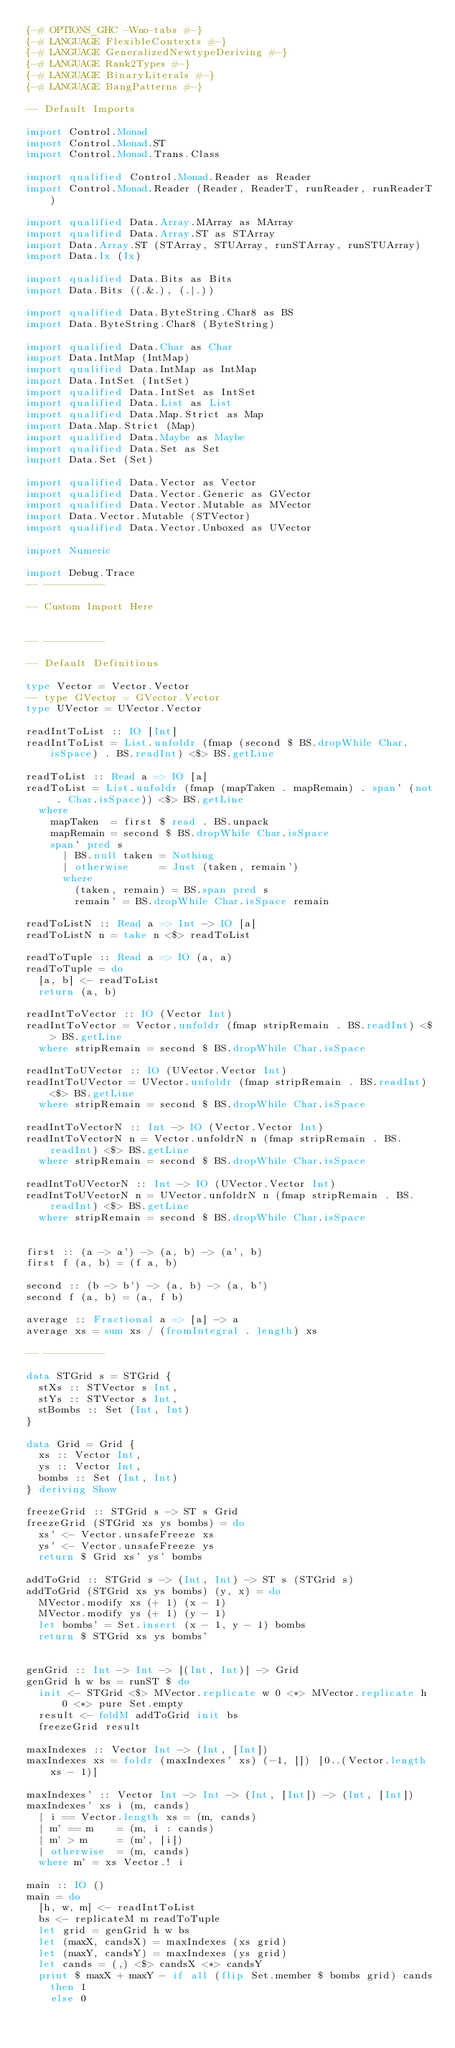Convert code to text. <code><loc_0><loc_0><loc_500><loc_500><_Haskell_>{-# OPTIONS_GHC -Wno-tabs #-}
{-# LANGUAGE FlexibleContexts #-}
{-# LANGUAGE GeneralizedNewtypeDeriving #-}
{-# LANGUAGE Rank2Types #-}
{-# LANGUAGE BinaryLiterals #-}
{-# LANGUAGE BangPatterns #-}

-- Default Imports

import Control.Monad
import Control.Monad.ST
import Control.Monad.Trans.Class

import qualified Control.Monad.Reader as Reader
import Control.Monad.Reader (Reader, ReaderT, runReader, runReaderT)

import qualified Data.Array.MArray as MArray
import qualified Data.Array.ST as STArray
import Data.Array.ST (STArray, STUArray, runSTArray, runSTUArray)
import Data.Ix (Ix)

import qualified Data.Bits as Bits
import Data.Bits ((.&.), (.|.))

import qualified Data.ByteString.Char8 as BS
import Data.ByteString.Char8 (ByteString)

import qualified Data.Char as Char
import Data.IntMap (IntMap)
import qualified Data.IntMap as IntMap
import Data.IntSet (IntSet)
import qualified Data.IntSet as IntSet
import qualified Data.List as List
import qualified Data.Map.Strict as Map
import Data.Map.Strict (Map)
import qualified Data.Maybe as Maybe
import qualified Data.Set as Set
import Data.Set (Set)

import qualified Data.Vector as Vector
import qualified Data.Vector.Generic as GVector
import qualified Data.Vector.Mutable as MVector
import Data.Vector.Mutable (STVector)
import qualified Data.Vector.Unboxed as UVector

import Numeric

import Debug.Trace
-- ----------

-- Custom Import Here


-- ----------

-- Default Definitions

type Vector = Vector.Vector
-- type GVector = GVector.Vector
type UVector = UVector.Vector

readIntToList :: IO [Int]
readIntToList = List.unfoldr (fmap (second $ BS.dropWhile Char.isSpace) . BS.readInt) <$> BS.getLine

readToList :: Read a => IO [a]
readToList = List.unfoldr (fmap (mapTaken . mapRemain) . span' (not . Char.isSpace)) <$> BS.getLine
	where
		mapTaken  = first $ read . BS.unpack
		mapRemain = second $ BS.dropWhile Char.isSpace
		span' pred s
			| BS.null taken = Nothing
			| otherwise     = Just (taken, remain')
			where
				(taken, remain) = BS.span pred s
				remain' = BS.dropWhile Char.isSpace remain

readToListN :: Read a => Int -> IO [a]
readToListN n = take n <$> readToList

readToTuple :: Read a => IO (a, a)
readToTuple = do
	[a, b] <- readToList
	return (a, b)

readIntToVector :: IO (Vector Int)
readIntToVector = Vector.unfoldr (fmap stripRemain . BS.readInt) <$> BS.getLine
	where stripRemain = second $ BS.dropWhile Char.isSpace

readIntToUVector :: IO (UVector.Vector Int)
readIntToUVector = UVector.unfoldr (fmap stripRemain . BS.readInt) <$> BS.getLine
	where stripRemain = second $ BS.dropWhile Char.isSpace

readIntToVectorN :: Int -> IO (Vector.Vector Int)
readIntToVectorN n = Vector.unfoldrN n (fmap stripRemain . BS.readInt) <$> BS.getLine
	where stripRemain = second $ BS.dropWhile Char.isSpace

readIntToUVectorN :: Int -> IO (UVector.Vector Int)
readIntToUVectorN n = UVector.unfoldrN n (fmap stripRemain . BS.readInt) <$> BS.getLine
	where stripRemain = second $ BS.dropWhile Char.isSpace


first :: (a -> a') -> (a, b) -> (a', b)
first f (a, b) = (f a, b)

second :: (b -> b') -> (a, b) -> (a, b')
second f (a, b) = (a, f b)

average :: Fractional a => [a] -> a
average xs = sum xs / (fromIntegral . length) xs

-- ----------

data STGrid s = STGrid {
	stXs :: STVector s Int,
	stYs :: STVector s Int,
	stBombs :: Set (Int, Int)
}

data Grid = Grid {
	xs :: Vector Int,
	ys :: Vector Int,
	bombs :: Set (Int, Int)
} deriving Show

freezeGrid :: STGrid s -> ST s Grid
freezeGrid (STGrid xs ys bombs) = do
	xs' <- Vector.unsafeFreeze xs
	ys' <- Vector.unsafeFreeze ys
	return $ Grid xs' ys' bombs

addToGrid :: STGrid s -> (Int, Int) -> ST s (STGrid s)
addToGrid (STGrid xs ys bombs) (y, x) = do
	MVector.modify xs (+ 1) (x - 1)
	MVector.modify ys (+ 1) (y - 1)
	let bombs' = Set.insert (x - 1, y - 1) bombs
	return $ STGrid xs ys bombs'


genGrid :: Int -> Int -> [(Int, Int)] -> Grid
genGrid h w bs = runST $ do
	init <- STGrid <$> MVector.replicate w 0 <*> MVector.replicate h 0 <*> pure Set.empty
	result <- foldM addToGrid init bs
	freezeGrid result

maxIndexes :: Vector Int -> (Int, [Int])
maxIndexes xs = foldr (maxIndexes' xs) (-1, []) [0..(Vector.length xs - 1)]

maxIndexes' :: Vector Int -> Int -> (Int, [Int]) -> (Int, [Int])
maxIndexes' xs i (m, cands)
	| i == Vector.length xs = (m, cands)
	| m' == m    = (m, i : cands)
	| m' > m     = (m', [i])
	| otherwise  = (m, cands)
	where m' = xs Vector.! i

main :: IO ()
main = do
	[h, w, m] <- readIntToList
	bs <- replicateM m readToTuple
	let grid = genGrid h w bs
	let (maxX, candsX) = maxIndexes (xs grid)
	let (maxY, candsY) = maxIndexes (ys grid)
	let cands = (,) <$> candsX <*> candsY
	print $ maxX + maxY - if all (flip Set.member $ bombs grid) cands
		then 1
		else 0
</code> 